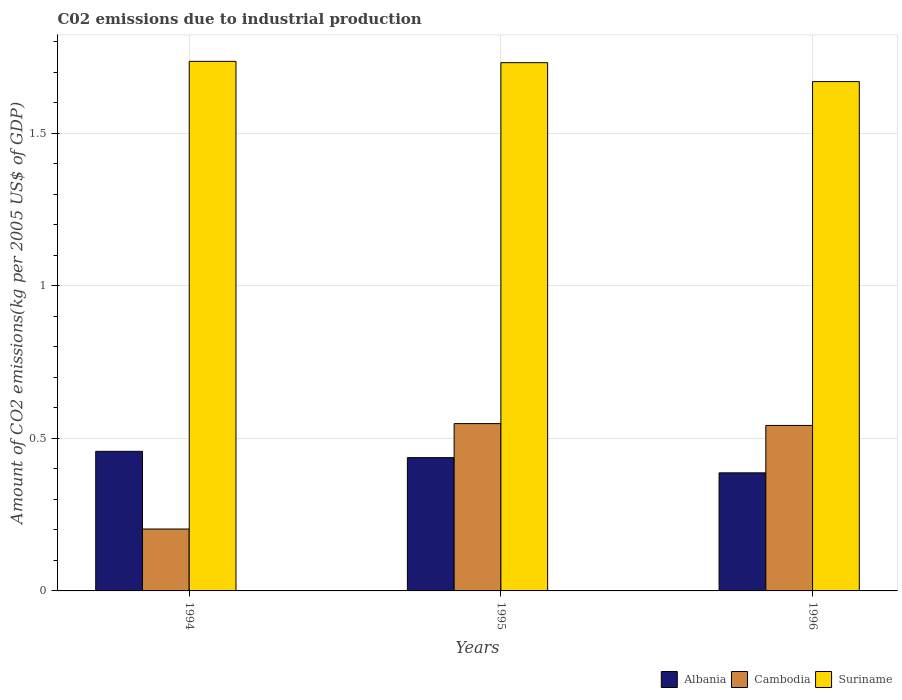How many different coloured bars are there?
Your response must be concise. 3. How many groups of bars are there?
Give a very brief answer. 3. Are the number of bars per tick equal to the number of legend labels?
Your response must be concise. Yes. Are the number of bars on each tick of the X-axis equal?
Give a very brief answer. Yes. How many bars are there on the 3rd tick from the left?
Your answer should be very brief. 3. What is the amount of CO2 emitted due to industrial production in Cambodia in 1995?
Make the answer very short. 0.55. Across all years, what is the maximum amount of CO2 emitted due to industrial production in Cambodia?
Provide a short and direct response. 0.55. Across all years, what is the minimum amount of CO2 emitted due to industrial production in Cambodia?
Offer a very short reply. 0.2. In which year was the amount of CO2 emitted due to industrial production in Cambodia maximum?
Give a very brief answer. 1995. In which year was the amount of CO2 emitted due to industrial production in Cambodia minimum?
Your answer should be compact. 1994. What is the total amount of CO2 emitted due to industrial production in Cambodia in the graph?
Your response must be concise. 1.29. What is the difference between the amount of CO2 emitted due to industrial production in Albania in 1994 and that in 1996?
Provide a succinct answer. 0.07. What is the difference between the amount of CO2 emitted due to industrial production in Cambodia in 1996 and the amount of CO2 emitted due to industrial production in Albania in 1994?
Ensure brevity in your answer.  0.08. What is the average amount of CO2 emitted due to industrial production in Cambodia per year?
Provide a short and direct response. 0.43. In the year 1995, what is the difference between the amount of CO2 emitted due to industrial production in Cambodia and amount of CO2 emitted due to industrial production in Suriname?
Ensure brevity in your answer.  -1.18. What is the ratio of the amount of CO2 emitted due to industrial production in Cambodia in 1994 to that in 1995?
Offer a terse response. 0.37. Is the amount of CO2 emitted due to industrial production in Cambodia in 1994 less than that in 1995?
Offer a terse response. Yes. Is the difference between the amount of CO2 emitted due to industrial production in Cambodia in 1994 and 1996 greater than the difference between the amount of CO2 emitted due to industrial production in Suriname in 1994 and 1996?
Offer a very short reply. No. What is the difference between the highest and the second highest amount of CO2 emitted due to industrial production in Albania?
Make the answer very short. 0.02. What is the difference between the highest and the lowest amount of CO2 emitted due to industrial production in Cambodia?
Provide a succinct answer. 0.35. In how many years, is the amount of CO2 emitted due to industrial production in Cambodia greater than the average amount of CO2 emitted due to industrial production in Cambodia taken over all years?
Provide a succinct answer. 2. What does the 3rd bar from the left in 1995 represents?
Offer a terse response. Suriname. What does the 1st bar from the right in 1996 represents?
Give a very brief answer. Suriname. Is it the case that in every year, the sum of the amount of CO2 emitted due to industrial production in Cambodia and amount of CO2 emitted due to industrial production in Albania is greater than the amount of CO2 emitted due to industrial production in Suriname?
Give a very brief answer. No. Are all the bars in the graph horizontal?
Keep it short and to the point. No. What is the difference between two consecutive major ticks on the Y-axis?
Make the answer very short. 0.5. Does the graph contain any zero values?
Your answer should be very brief. No. Where does the legend appear in the graph?
Your response must be concise. Bottom right. How many legend labels are there?
Keep it short and to the point. 3. How are the legend labels stacked?
Offer a very short reply. Horizontal. What is the title of the graph?
Your answer should be compact. C02 emissions due to industrial production. What is the label or title of the X-axis?
Your answer should be compact. Years. What is the label or title of the Y-axis?
Offer a terse response. Amount of CO2 emissions(kg per 2005 US$ of GDP). What is the Amount of CO2 emissions(kg per 2005 US$ of GDP) in Albania in 1994?
Make the answer very short. 0.46. What is the Amount of CO2 emissions(kg per 2005 US$ of GDP) of Cambodia in 1994?
Your response must be concise. 0.2. What is the Amount of CO2 emissions(kg per 2005 US$ of GDP) of Suriname in 1994?
Your answer should be very brief. 1.74. What is the Amount of CO2 emissions(kg per 2005 US$ of GDP) of Albania in 1995?
Ensure brevity in your answer.  0.44. What is the Amount of CO2 emissions(kg per 2005 US$ of GDP) of Cambodia in 1995?
Make the answer very short. 0.55. What is the Amount of CO2 emissions(kg per 2005 US$ of GDP) in Suriname in 1995?
Provide a short and direct response. 1.73. What is the Amount of CO2 emissions(kg per 2005 US$ of GDP) of Albania in 1996?
Offer a terse response. 0.39. What is the Amount of CO2 emissions(kg per 2005 US$ of GDP) of Cambodia in 1996?
Provide a succinct answer. 0.54. What is the Amount of CO2 emissions(kg per 2005 US$ of GDP) of Suriname in 1996?
Offer a terse response. 1.67. Across all years, what is the maximum Amount of CO2 emissions(kg per 2005 US$ of GDP) of Albania?
Your answer should be very brief. 0.46. Across all years, what is the maximum Amount of CO2 emissions(kg per 2005 US$ of GDP) of Cambodia?
Give a very brief answer. 0.55. Across all years, what is the maximum Amount of CO2 emissions(kg per 2005 US$ of GDP) of Suriname?
Your response must be concise. 1.74. Across all years, what is the minimum Amount of CO2 emissions(kg per 2005 US$ of GDP) in Albania?
Ensure brevity in your answer.  0.39. Across all years, what is the minimum Amount of CO2 emissions(kg per 2005 US$ of GDP) of Cambodia?
Ensure brevity in your answer.  0.2. Across all years, what is the minimum Amount of CO2 emissions(kg per 2005 US$ of GDP) in Suriname?
Your answer should be compact. 1.67. What is the total Amount of CO2 emissions(kg per 2005 US$ of GDP) in Albania in the graph?
Offer a very short reply. 1.28. What is the total Amount of CO2 emissions(kg per 2005 US$ of GDP) of Cambodia in the graph?
Your response must be concise. 1.29. What is the total Amount of CO2 emissions(kg per 2005 US$ of GDP) of Suriname in the graph?
Provide a short and direct response. 5.13. What is the difference between the Amount of CO2 emissions(kg per 2005 US$ of GDP) in Albania in 1994 and that in 1995?
Give a very brief answer. 0.02. What is the difference between the Amount of CO2 emissions(kg per 2005 US$ of GDP) of Cambodia in 1994 and that in 1995?
Offer a very short reply. -0.35. What is the difference between the Amount of CO2 emissions(kg per 2005 US$ of GDP) in Suriname in 1994 and that in 1995?
Provide a short and direct response. 0. What is the difference between the Amount of CO2 emissions(kg per 2005 US$ of GDP) of Albania in 1994 and that in 1996?
Keep it short and to the point. 0.07. What is the difference between the Amount of CO2 emissions(kg per 2005 US$ of GDP) in Cambodia in 1994 and that in 1996?
Keep it short and to the point. -0.34. What is the difference between the Amount of CO2 emissions(kg per 2005 US$ of GDP) in Suriname in 1994 and that in 1996?
Provide a short and direct response. 0.07. What is the difference between the Amount of CO2 emissions(kg per 2005 US$ of GDP) in Albania in 1995 and that in 1996?
Ensure brevity in your answer.  0.05. What is the difference between the Amount of CO2 emissions(kg per 2005 US$ of GDP) in Cambodia in 1995 and that in 1996?
Provide a succinct answer. 0.01. What is the difference between the Amount of CO2 emissions(kg per 2005 US$ of GDP) in Suriname in 1995 and that in 1996?
Your answer should be very brief. 0.06. What is the difference between the Amount of CO2 emissions(kg per 2005 US$ of GDP) of Albania in 1994 and the Amount of CO2 emissions(kg per 2005 US$ of GDP) of Cambodia in 1995?
Your answer should be very brief. -0.09. What is the difference between the Amount of CO2 emissions(kg per 2005 US$ of GDP) of Albania in 1994 and the Amount of CO2 emissions(kg per 2005 US$ of GDP) of Suriname in 1995?
Your response must be concise. -1.27. What is the difference between the Amount of CO2 emissions(kg per 2005 US$ of GDP) of Cambodia in 1994 and the Amount of CO2 emissions(kg per 2005 US$ of GDP) of Suriname in 1995?
Give a very brief answer. -1.53. What is the difference between the Amount of CO2 emissions(kg per 2005 US$ of GDP) of Albania in 1994 and the Amount of CO2 emissions(kg per 2005 US$ of GDP) of Cambodia in 1996?
Your answer should be very brief. -0.08. What is the difference between the Amount of CO2 emissions(kg per 2005 US$ of GDP) of Albania in 1994 and the Amount of CO2 emissions(kg per 2005 US$ of GDP) of Suriname in 1996?
Provide a short and direct response. -1.21. What is the difference between the Amount of CO2 emissions(kg per 2005 US$ of GDP) of Cambodia in 1994 and the Amount of CO2 emissions(kg per 2005 US$ of GDP) of Suriname in 1996?
Keep it short and to the point. -1.47. What is the difference between the Amount of CO2 emissions(kg per 2005 US$ of GDP) in Albania in 1995 and the Amount of CO2 emissions(kg per 2005 US$ of GDP) in Cambodia in 1996?
Provide a succinct answer. -0.11. What is the difference between the Amount of CO2 emissions(kg per 2005 US$ of GDP) in Albania in 1995 and the Amount of CO2 emissions(kg per 2005 US$ of GDP) in Suriname in 1996?
Offer a terse response. -1.23. What is the difference between the Amount of CO2 emissions(kg per 2005 US$ of GDP) of Cambodia in 1995 and the Amount of CO2 emissions(kg per 2005 US$ of GDP) of Suriname in 1996?
Give a very brief answer. -1.12. What is the average Amount of CO2 emissions(kg per 2005 US$ of GDP) in Albania per year?
Your response must be concise. 0.43. What is the average Amount of CO2 emissions(kg per 2005 US$ of GDP) of Cambodia per year?
Provide a succinct answer. 0.43. What is the average Amount of CO2 emissions(kg per 2005 US$ of GDP) of Suriname per year?
Your response must be concise. 1.71. In the year 1994, what is the difference between the Amount of CO2 emissions(kg per 2005 US$ of GDP) in Albania and Amount of CO2 emissions(kg per 2005 US$ of GDP) in Cambodia?
Offer a very short reply. 0.25. In the year 1994, what is the difference between the Amount of CO2 emissions(kg per 2005 US$ of GDP) of Albania and Amount of CO2 emissions(kg per 2005 US$ of GDP) of Suriname?
Keep it short and to the point. -1.28. In the year 1994, what is the difference between the Amount of CO2 emissions(kg per 2005 US$ of GDP) in Cambodia and Amount of CO2 emissions(kg per 2005 US$ of GDP) in Suriname?
Provide a succinct answer. -1.53. In the year 1995, what is the difference between the Amount of CO2 emissions(kg per 2005 US$ of GDP) in Albania and Amount of CO2 emissions(kg per 2005 US$ of GDP) in Cambodia?
Offer a terse response. -0.11. In the year 1995, what is the difference between the Amount of CO2 emissions(kg per 2005 US$ of GDP) in Albania and Amount of CO2 emissions(kg per 2005 US$ of GDP) in Suriname?
Your response must be concise. -1.29. In the year 1995, what is the difference between the Amount of CO2 emissions(kg per 2005 US$ of GDP) in Cambodia and Amount of CO2 emissions(kg per 2005 US$ of GDP) in Suriname?
Offer a very short reply. -1.18. In the year 1996, what is the difference between the Amount of CO2 emissions(kg per 2005 US$ of GDP) of Albania and Amount of CO2 emissions(kg per 2005 US$ of GDP) of Cambodia?
Make the answer very short. -0.16. In the year 1996, what is the difference between the Amount of CO2 emissions(kg per 2005 US$ of GDP) of Albania and Amount of CO2 emissions(kg per 2005 US$ of GDP) of Suriname?
Provide a succinct answer. -1.28. In the year 1996, what is the difference between the Amount of CO2 emissions(kg per 2005 US$ of GDP) of Cambodia and Amount of CO2 emissions(kg per 2005 US$ of GDP) of Suriname?
Provide a short and direct response. -1.13. What is the ratio of the Amount of CO2 emissions(kg per 2005 US$ of GDP) in Albania in 1994 to that in 1995?
Provide a short and direct response. 1.05. What is the ratio of the Amount of CO2 emissions(kg per 2005 US$ of GDP) of Cambodia in 1994 to that in 1995?
Provide a short and direct response. 0.37. What is the ratio of the Amount of CO2 emissions(kg per 2005 US$ of GDP) of Albania in 1994 to that in 1996?
Provide a succinct answer. 1.18. What is the ratio of the Amount of CO2 emissions(kg per 2005 US$ of GDP) of Cambodia in 1994 to that in 1996?
Provide a succinct answer. 0.37. What is the ratio of the Amount of CO2 emissions(kg per 2005 US$ of GDP) of Suriname in 1994 to that in 1996?
Provide a succinct answer. 1.04. What is the ratio of the Amount of CO2 emissions(kg per 2005 US$ of GDP) of Albania in 1995 to that in 1996?
Your response must be concise. 1.13. What is the ratio of the Amount of CO2 emissions(kg per 2005 US$ of GDP) in Cambodia in 1995 to that in 1996?
Provide a succinct answer. 1.01. What is the ratio of the Amount of CO2 emissions(kg per 2005 US$ of GDP) of Suriname in 1995 to that in 1996?
Give a very brief answer. 1.04. What is the difference between the highest and the second highest Amount of CO2 emissions(kg per 2005 US$ of GDP) of Albania?
Your response must be concise. 0.02. What is the difference between the highest and the second highest Amount of CO2 emissions(kg per 2005 US$ of GDP) in Cambodia?
Keep it short and to the point. 0.01. What is the difference between the highest and the second highest Amount of CO2 emissions(kg per 2005 US$ of GDP) of Suriname?
Your answer should be very brief. 0. What is the difference between the highest and the lowest Amount of CO2 emissions(kg per 2005 US$ of GDP) of Albania?
Offer a very short reply. 0.07. What is the difference between the highest and the lowest Amount of CO2 emissions(kg per 2005 US$ of GDP) in Cambodia?
Your response must be concise. 0.35. What is the difference between the highest and the lowest Amount of CO2 emissions(kg per 2005 US$ of GDP) of Suriname?
Make the answer very short. 0.07. 